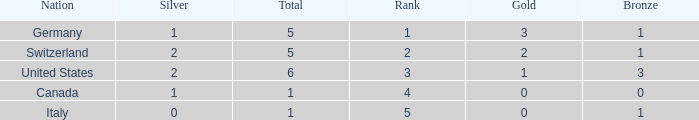How many golds for nations with over 0 silvers, over 1 total, and over 3 bronze? 0.0. 